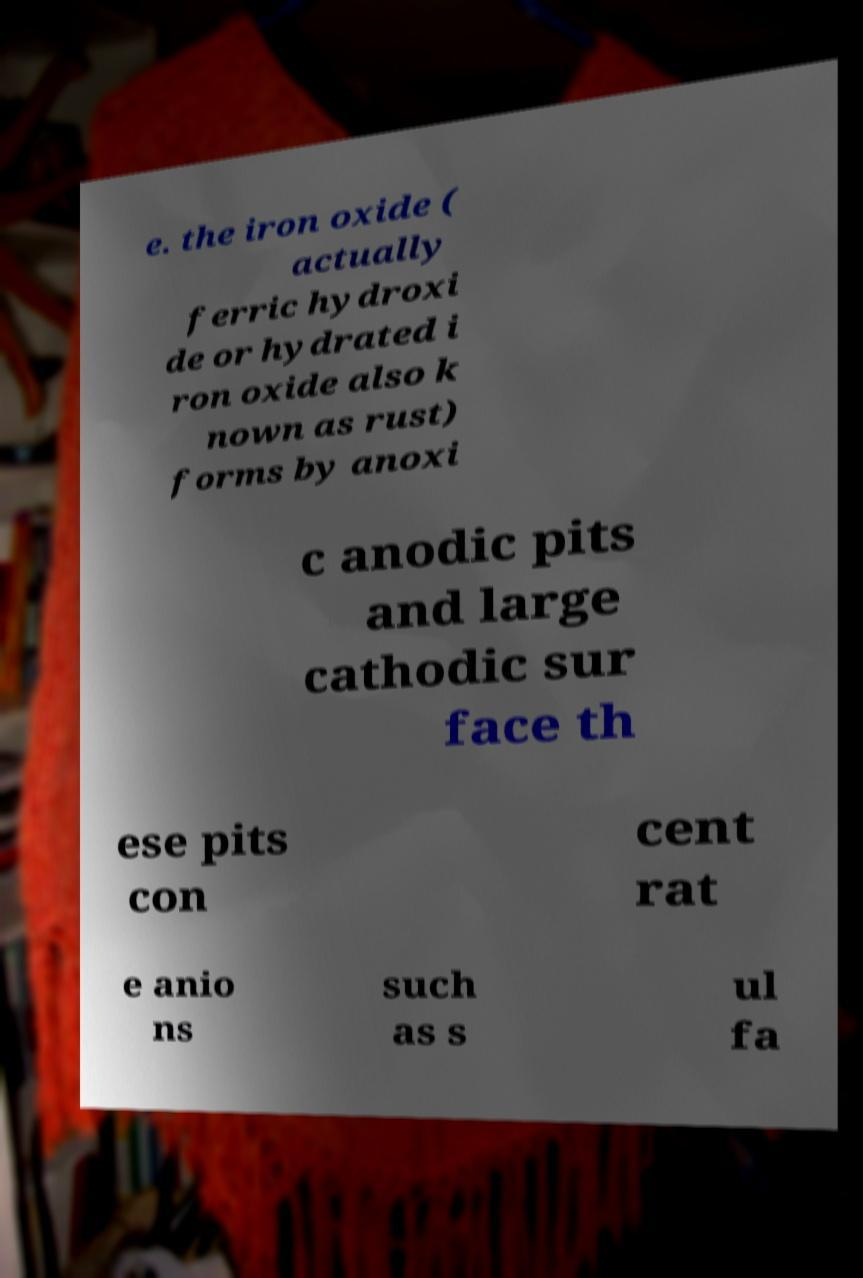For documentation purposes, I need the text within this image transcribed. Could you provide that? e. the iron oxide ( actually ferric hydroxi de or hydrated i ron oxide also k nown as rust) forms by anoxi c anodic pits and large cathodic sur face th ese pits con cent rat e anio ns such as s ul fa 